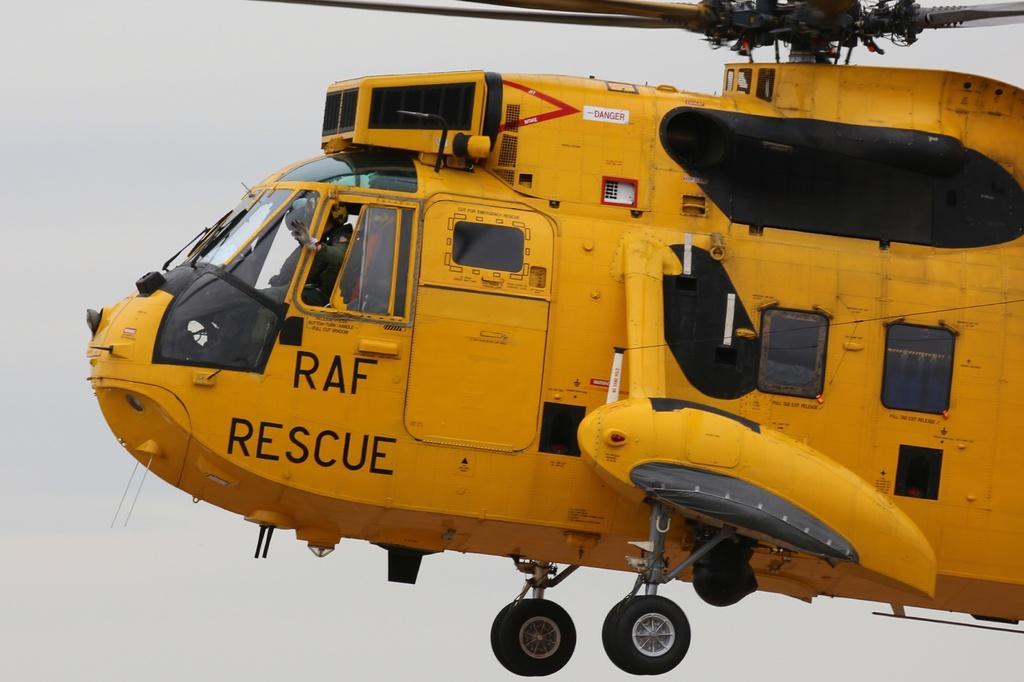In one or two sentences, can you explain what this image depicts? In this image there is a yellow colour helicopter flying in air. Few persons are inside it. Background there is sky. 